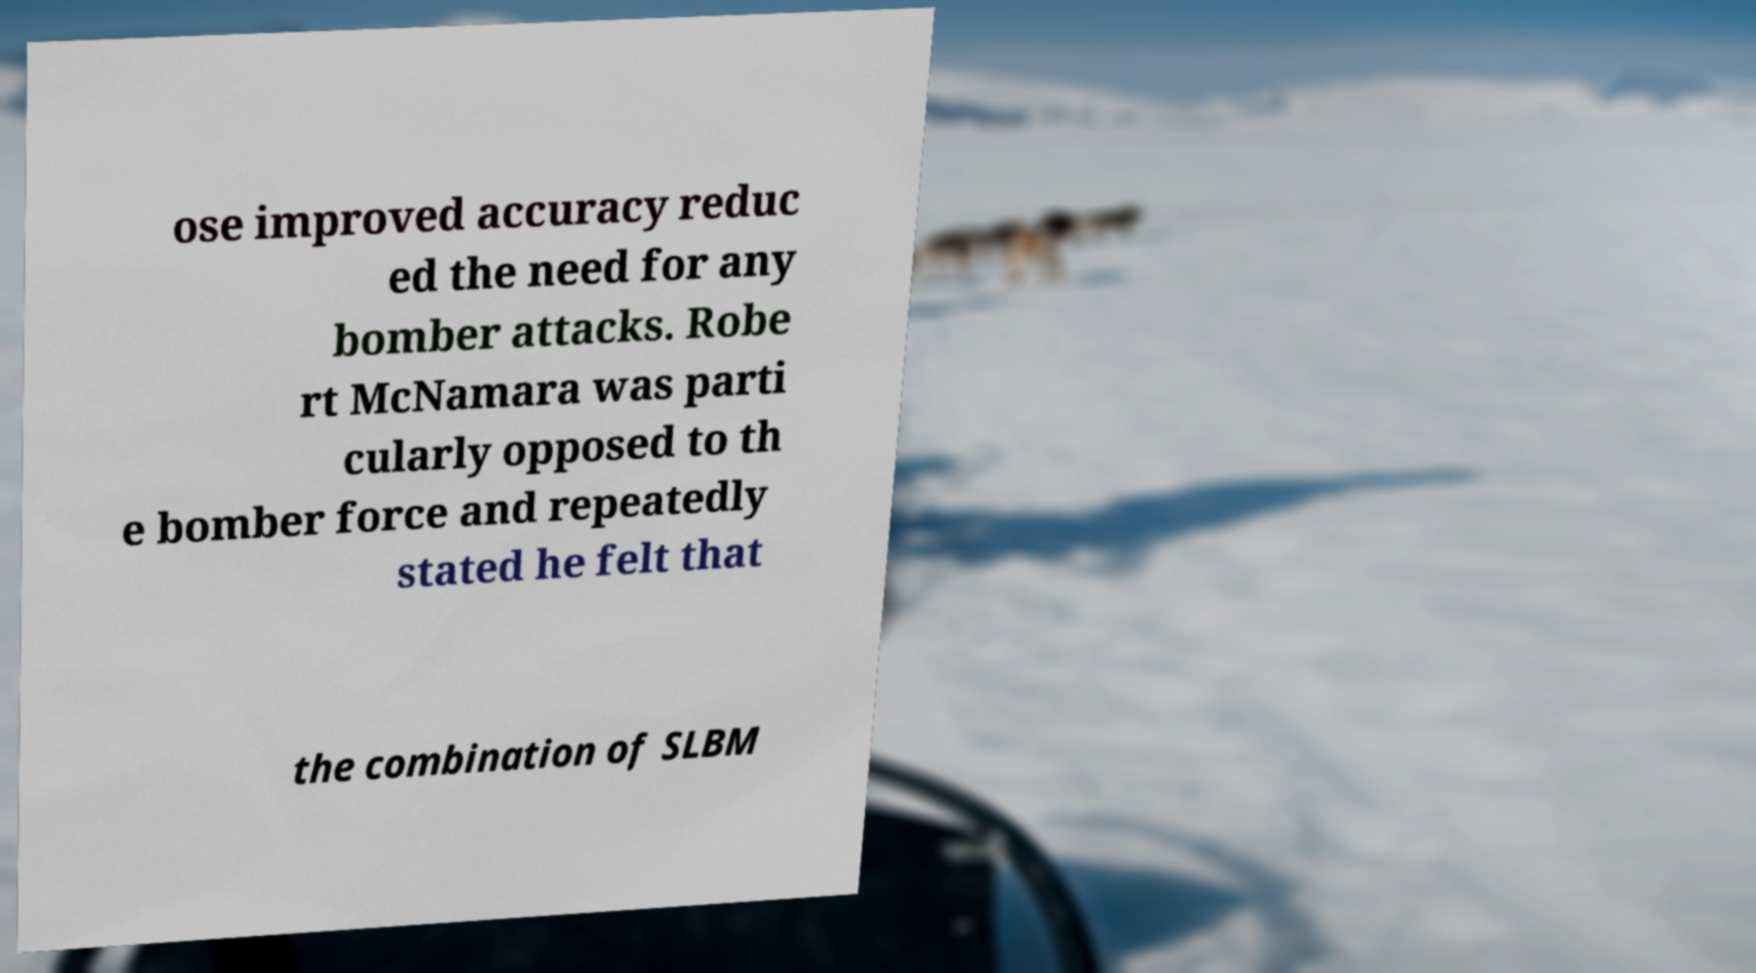Please read and relay the text visible in this image. What does it say? ose improved accuracy reduc ed the need for any bomber attacks. Robe rt McNamara was parti cularly opposed to th e bomber force and repeatedly stated he felt that the combination of SLBM 